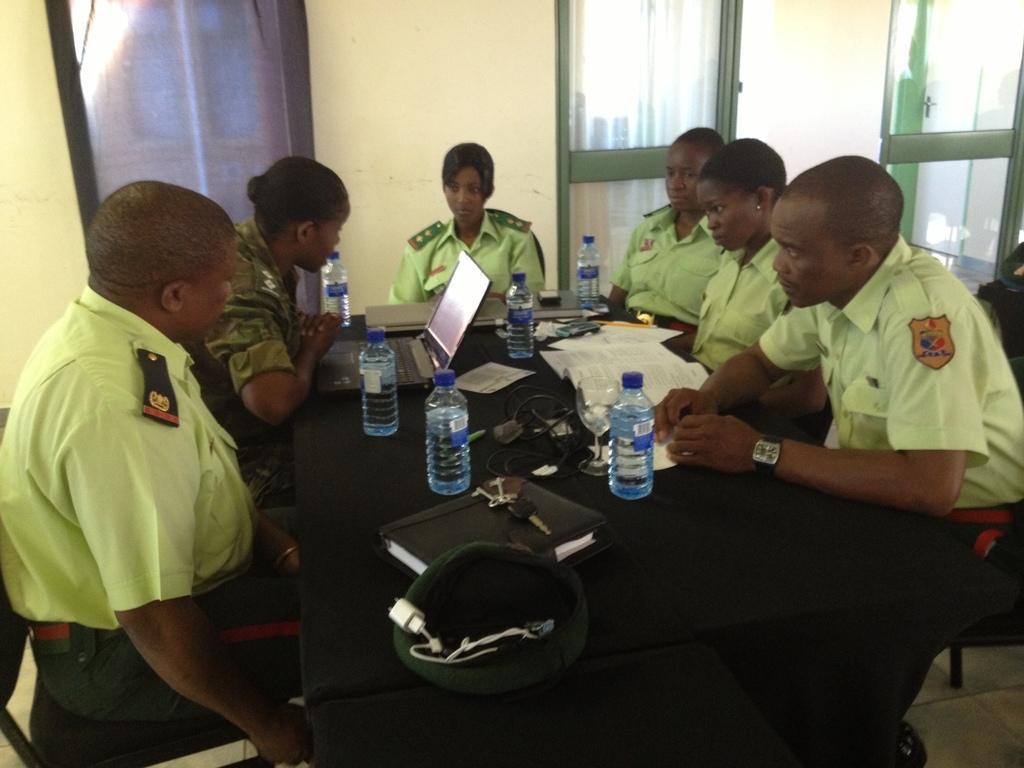Can you describe this image briefly? A group of people are sitting together around the table. They wore green color shirts, there are water bottles on this table. 